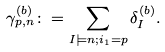Convert formula to latex. <formula><loc_0><loc_0><loc_500><loc_500>\gamma ^ { ( b ) } _ { p , n } \colon = \sum _ { I \models n ; i _ { 1 } = p } \delta ^ { ( b ) } _ { I } .</formula> 